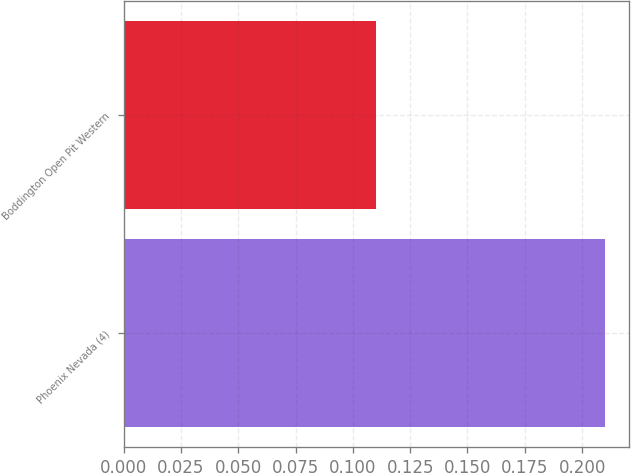Convert chart. <chart><loc_0><loc_0><loc_500><loc_500><bar_chart><fcel>Phoenix Nevada (4)<fcel>Boddington Open Pit Western<nl><fcel>0.21<fcel>0.11<nl></chart> 